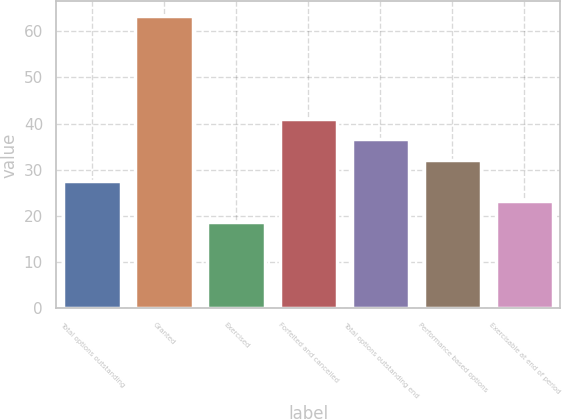Convert chart to OTSL. <chart><loc_0><loc_0><loc_500><loc_500><bar_chart><fcel>Total options outstanding<fcel>Granted<fcel>Exercised<fcel>Forfeited and cancelled<fcel>Total options outstanding end<fcel>Performance based options<fcel>Exercisable at end of period<nl><fcel>27.67<fcel>63.23<fcel>18.77<fcel>41.02<fcel>36.57<fcel>32.12<fcel>23.22<nl></chart> 